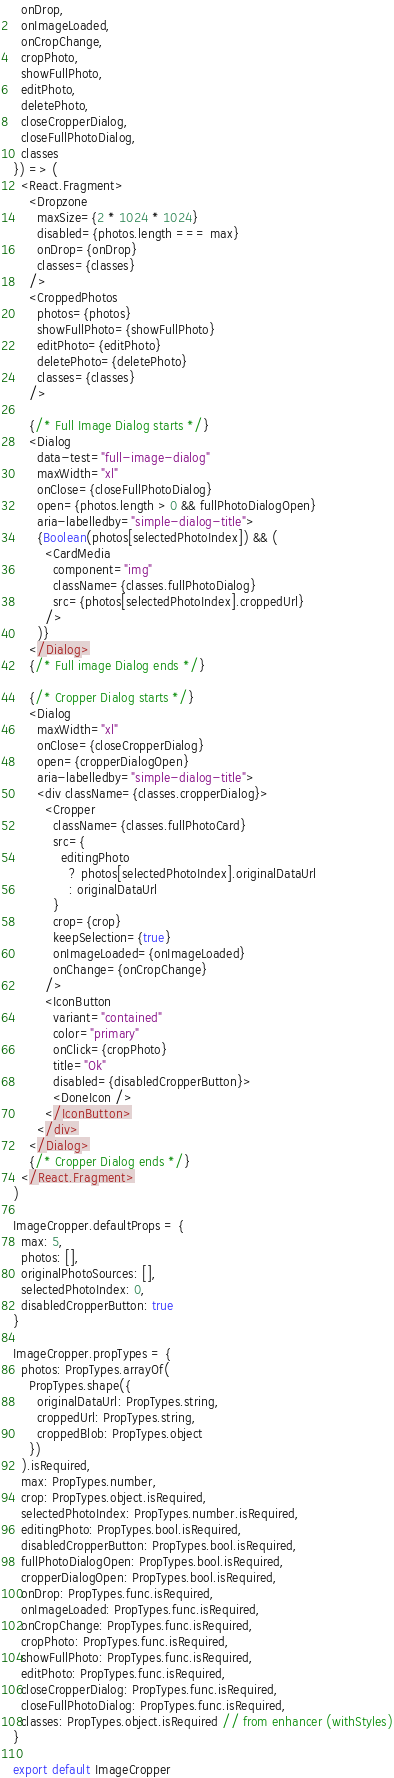<code> <loc_0><loc_0><loc_500><loc_500><_JavaScript_>  onDrop,
  onImageLoaded,
  onCropChange,
  cropPhoto,
  showFullPhoto,
  editPhoto,
  deletePhoto,
  closeCropperDialog,
  closeFullPhotoDialog,
  classes
}) => (
  <React.Fragment>
    <Dropzone
      maxSize={2 * 1024 * 1024}
      disabled={photos.length === max}
      onDrop={onDrop}
      classes={classes}
    />
    <CroppedPhotos
      photos={photos}
      showFullPhoto={showFullPhoto}
      editPhoto={editPhoto}
      deletePhoto={deletePhoto}
      classes={classes}
    />

    {/* Full Image Dialog starts */}
    <Dialog
      data-test="full-image-dialog"
      maxWidth="xl"
      onClose={closeFullPhotoDialog}
      open={photos.length > 0 && fullPhotoDialogOpen}
      aria-labelledby="simple-dialog-title">
      {Boolean(photos[selectedPhotoIndex]) && (
        <CardMedia
          component="img"
          className={classes.fullPhotoDialog}
          src={photos[selectedPhotoIndex].croppedUrl}
        />
      )}
    </Dialog>
    {/* Full image Dialog ends */}

    {/* Cropper Dialog starts */}
    <Dialog
      maxWidth="xl"
      onClose={closeCropperDialog}
      open={cropperDialogOpen}
      aria-labelledby="simple-dialog-title">
      <div className={classes.cropperDialog}>
        <Cropper
          className={classes.fullPhotoCard}
          src={
            editingPhoto
              ? photos[selectedPhotoIndex].originalDataUrl
              : originalDataUrl
          }
          crop={crop}
          keepSelection={true}
          onImageLoaded={onImageLoaded}
          onChange={onCropChange}
        />
        <IconButton
          variant="contained"
          color="primary"
          onClick={cropPhoto}
          title="Ok"
          disabled={disabledCropperButton}>
          <DoneIcon />
        </IconButton>
      </div>
    </Dialog>
    {/* Cropper Dialog ends */}
  </React.Fragment>
)

ImageCropper.defaultProps = {
  max: 5,
  photos: [],
  originalPhotoSources: [],
  selectedPhotoIndex: 0,
  disabledCropperButton: true
}

ImageCropper.propTypes = {
  photos: PropTypes.arrayOf(
    PropTypes.shape({
      originalDataUrl: PropTypes.string,
      croppedUrl: PropTypes.string,
      croppedBlob: PropTypes.object
    })
  ).isRequired,
  max: PropTypes.number,
  crop: PropTypes.object.isRequired,
  selectedPhotoIndex: PropTypes.number.isRequired,
  editingPhoto: PropTypes.bool.isRequired,
  disabledCropperButton: PropTypes.bool.isRequired,
  fullPhotoDialogOpen: PropTypes.bool.isRequired,
  cropperDialogOpen: PropTypes.bool.isRequired,
  onDrop: PropTypes.func.isRequired,
  onImageLoaded: PropTypes.func.isRequired,
  onCropChange: PropTypes.func.isRequired,
  cropPhoto: PropTypes.func.isRequired,
  showFullPhoto: PropTypes.func.isRequired,
  editPhoto: PropTypes.func.isRequired,
  closeCropperDialog: PropTypes.func.isRequired,
  closeFullPhotoDialog: PropTypes.func.isRequired,
  classes: PropTypes.object.isRequired // from enhancer (withStyles)
}

export default ImageCropper
</code> 